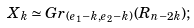Convert formula to latex. <formula><loc_0><loc_0><loc_500><loc_500>X _ { k } \simeq G r _ { ( e _ { 1 } - k , e _ { 2 } - k ) } ( R _ { n - 2 k } ) ;</formula> 